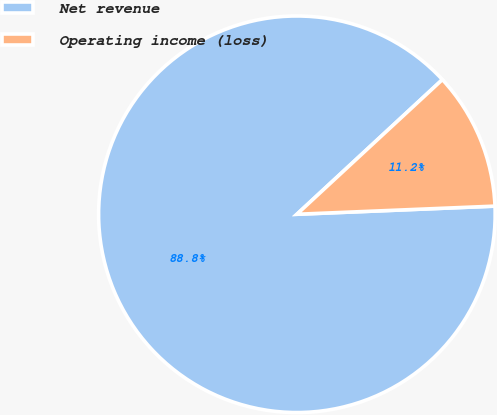Convert chart to OTSL. <chart><loc_0><loc_0><loc_500><loc_500><pie_chart><fcel>Net revenue<fcel>Operating income (loss)<nl><fcel>88.77%<fcel>11.23%<nl></chart> 